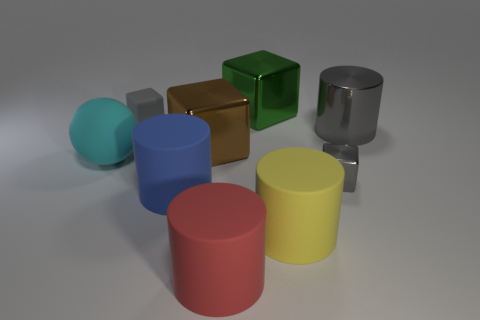Subtract 1 blocks. How many blocks are left? 3 Subtract all green cubes. Subtract all red cylinders. How many cubes are left? 3 Subtract all cubes. How many objects are left? 5 Subtract 1 cyan spheres. How many objects are left? 8 Subtract all cyan rubber objects. Subtract all big cubes. How many objects are left? 6 Add 3 big rubber cylinders. How many big rubber cylinders are left? 6 Add 2 large gray things. How many large gray things exist? 3 